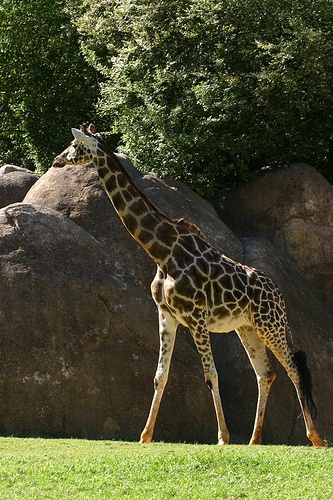Describe the objects in this image and their specific colors. I can see a giraffe in darkgreen, black, tan, olive, and gray tones in this image. 